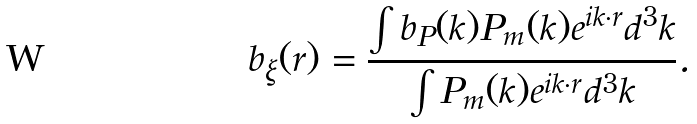<formula> <loc_0><loc_0><loc_500><loc_500>b _ { \xi } ( r ) = \frac { \int b _ { P } ( k ) P _ { m } ( k ) e ^ { i { k } \cdot { r } } d ^ { 3 } k } { \int P _ { m } ( k ) e ^ { i { k } \cdot { r } } d ^ { 3 } k } .</formula> 